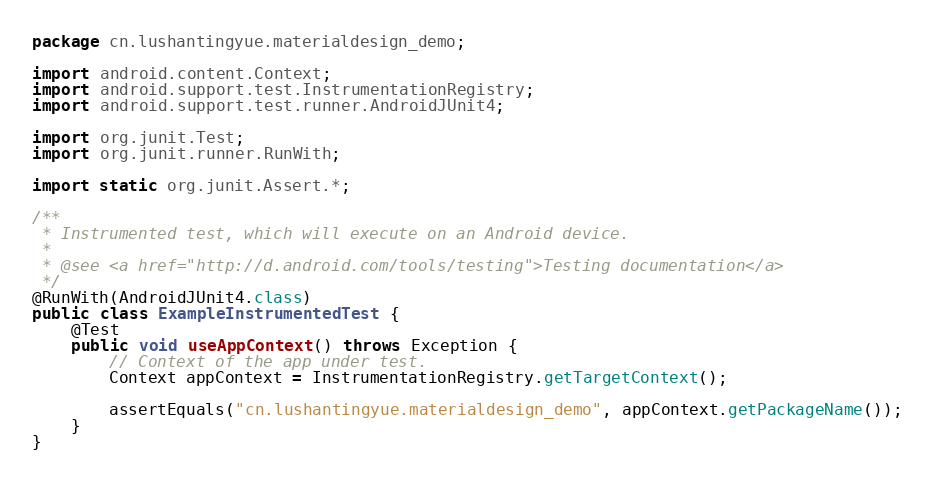<code> <loc_0><loc_0><loc_500><loc_500><_Java_>package cn.lushantingyue.materialdesign_demo;

import android.content.Context;
import android.support.test.InstrumentationRegistry;
import android.support.test.runner.AndroidJUnit4;

import org.junit.Test;
import org.junit.runner.RunWith;

import static org.junit.Assert.*;

/**
 * Instrumented test, which will execute on an Android device.
 *
 * @see <a href="http://d.android.com/tools/testing">Testing documentation</a>
 */
@RunWith(AndroidJUnit4.class)
public class ExampleInstrumentedTest {
    @Test
    public void useAppContext() throws Exception {
        // Context of the app under test.
        Context appContext = InstrumentationRegistry.getTargetContext();

        assertEquals("cn.lushantingyue.materialdesign_demo", appContext.getPackageName());
    }
}
</code> 